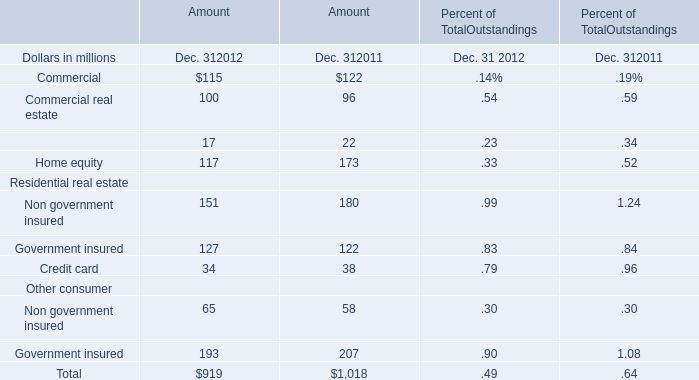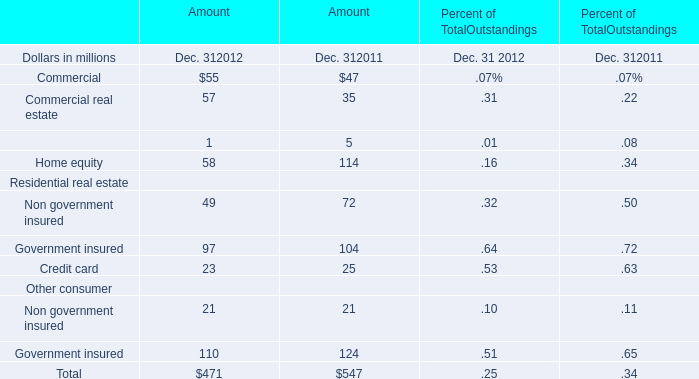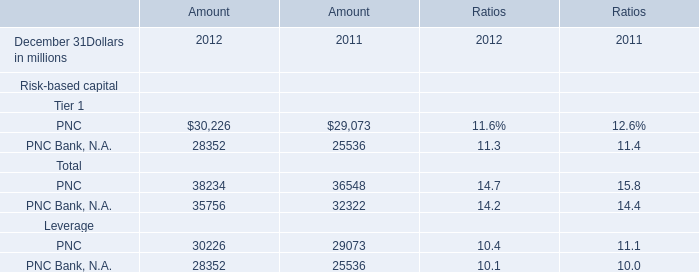If Home equity develops with the same increasing rate in 2012, what will it reach in 2013? (in million) 
Computations: ((1 + ((117 - 173) / 173)) * 117)
Answer: 79.12717. 